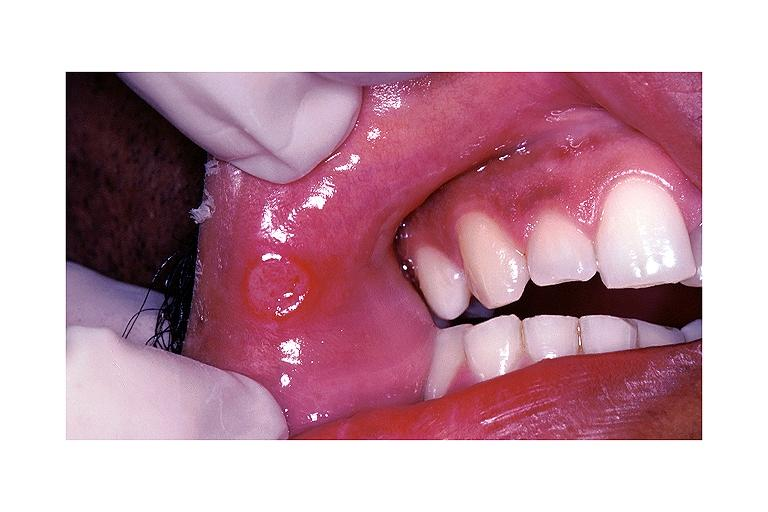where is this?
Answer the question using a single word or phrase. Oral 